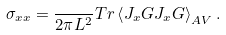Convert formula to latex. <formula><loc_0><loc_0><loc_500><loc_500>\sigma _ { x x } = \frac { } { 2 \pi L ^ { 2 } } T r \left \langle J _ { x } G J _ { x } G \right \rangle _ { A V } .</formula> 